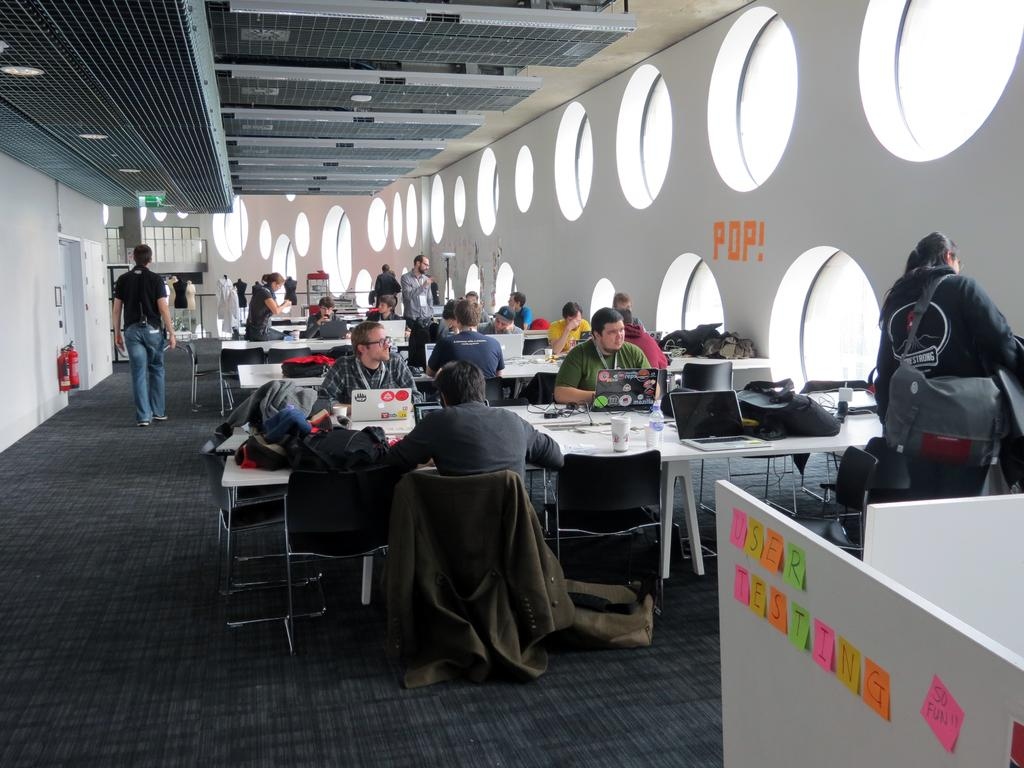<image>
Present a compact description of the photo's key features. A workspace with round windows and the word POP on the wall. 